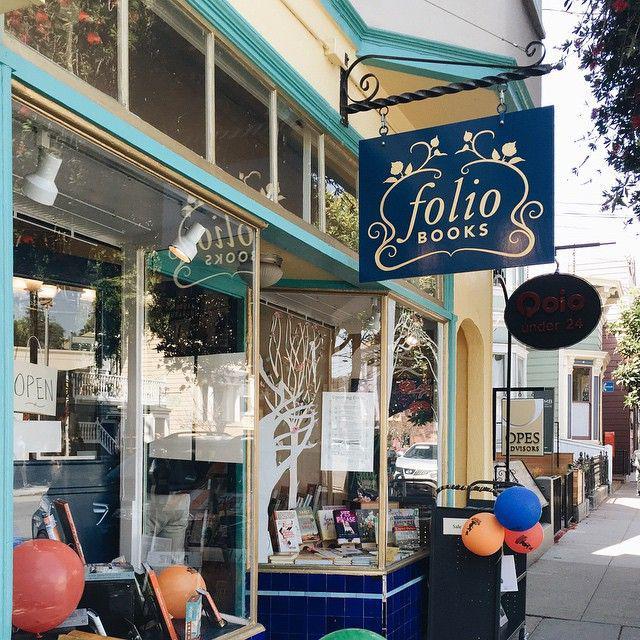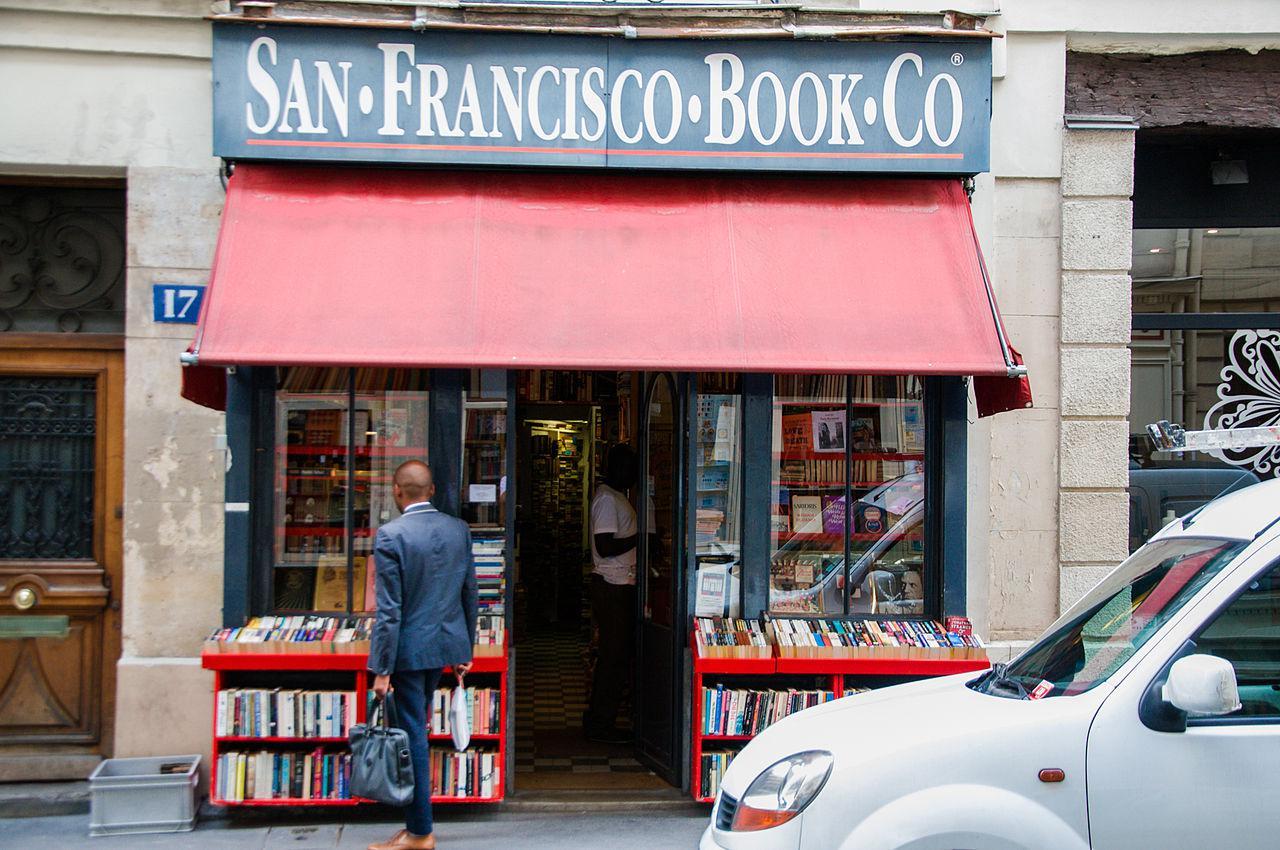The first image is the image on the left, the second image is the image on the right. Given the left and right images, does the statement "An awning hangs over the business in the image on the right." hold true? Answer yes or no. Yes. The first image is the image on the left, the second image is the image on the right. Given the left and right images, does the statement "There are two set of red bookshelves outside filled with books, under a red awning." hold true? Answer yes or no. Yes. 